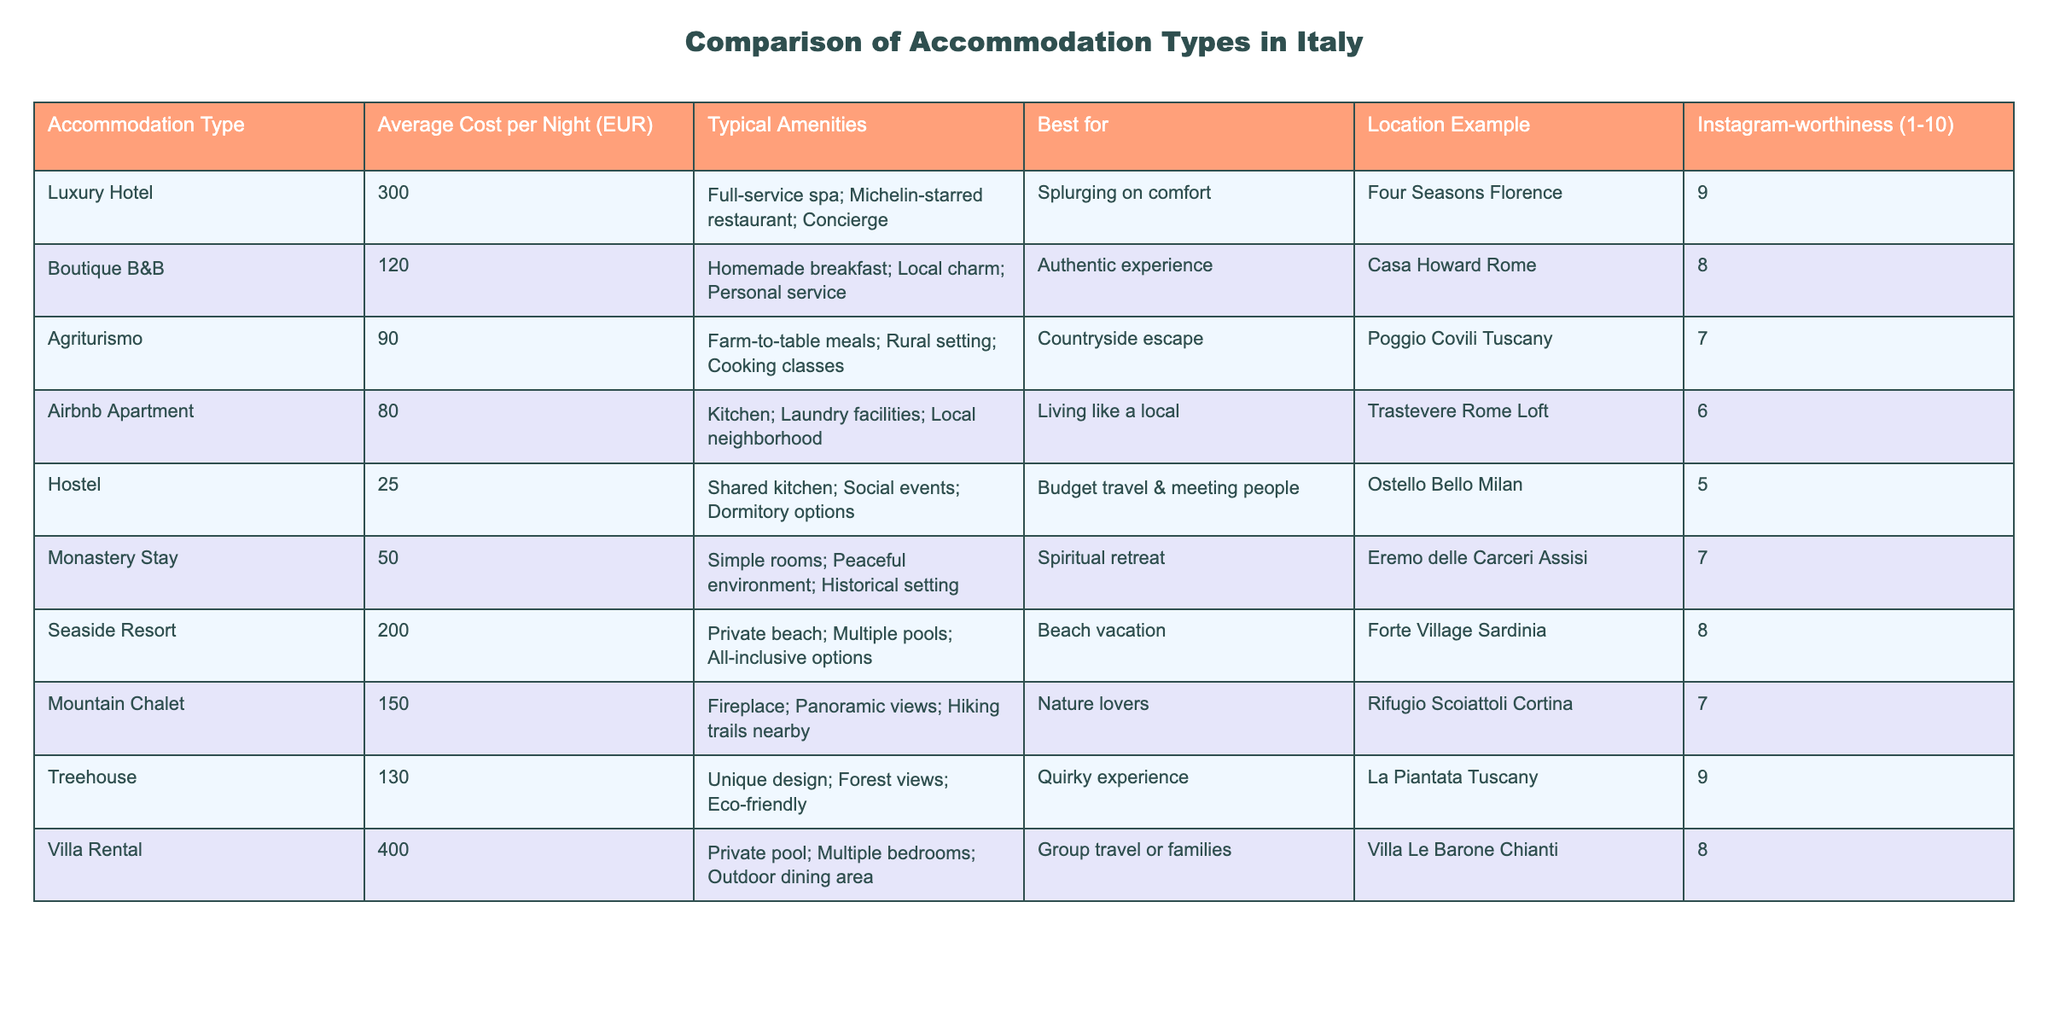What is the average cost per night of an Agriturismo accommodation? The table indicates that the average cost per night for an Agriturismo accommodation is 90 EUR.
Answer: 90 EUR Which accommodation type offers the highest Instagram-worthiness score? The table shows that Villa Rental has the highest Instagram-worthiness score of 8.
Answer: 8 How much more expensive is a Luxury Hotel compared to a Hostel? The average cost per night for a Luxury Hotel is 300 EUR, while for a Hostel it is 25 EUR. The difference is 300 - 25 = 275 EUR.
Answer: 275 EUR Is the average cost per night for a Treehouse higher than that for an Airbnb Apartment? The average cost per night for a Treehouse is 130 EUR, and for an Airbnb Apartment, it is 80 EUR. Since 130 is greater than 80, the statement is true.
Answer: Yes If you combine the average costs of a Villa Rental and a Seaside Resort, what is the total? The average cost per night for a Villa Rental is 400 EUR and for a Seaside Resort is 200 EUR. Adding these together gives 400 + 200 = 600 EUR.
Answer: 600 EUR Which accommodation type is best for a spiritual retreat? The table indicates that a Monastery Stay is best for a spiritual retreat, as denoted in the Best for column.
Answer: Monastery Stay What is the cost per night range among all accommodations, from cheapest to most expensive? Hostels are the cheapest at 25 EUR, and Villa Rentals are the most expensive at 400 EUR, giving a range of (400 - 25) = 375 EUR.
Answer: 375 EUR How does the average cost of a Mountain Chalet compare to that of a Boutique B&B? The average cost for a Mountain Chalet is 150 EUR and for a Boutique B&B is 120 EUR. So, the Mountain Chalet is 30 EUR more expensive than the Boutique B&B.
Answer: 30 EUR Is an Airbnb Apartment more Instagram-worthy than an Agriturismo accommodation? The Instagram-worthiness score for Airbnb Apartments is 6 and for Agriturismo is 7. Since 6 is less than 7, the claim is false.
Answer: No 